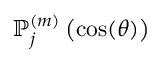Convert formula to latex. <formula><loc_0><loc_0><loc_500><loc_500>\mathbb { P } _ { j } ^ { ( m ) } \left ( \cos ( \theta ) \right )</formula> 